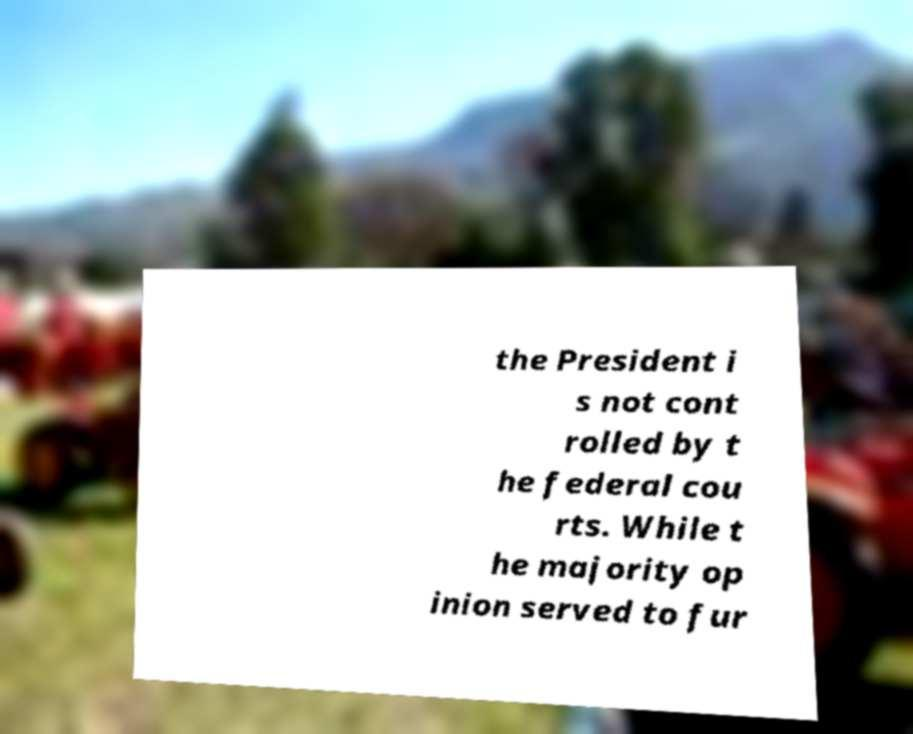For documentation purposes, I need the text within this image transcribed. Could you provide that? the President i s not cont rolled by t he federal cou rts. While t he majority op inion served to fur 